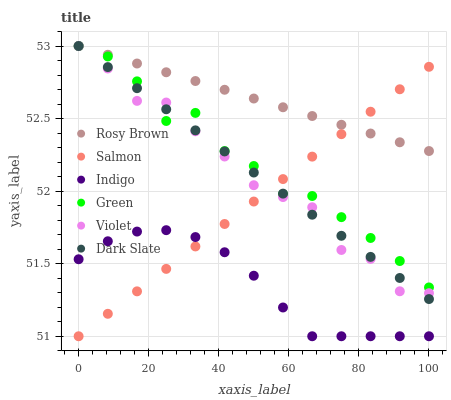Does Indigo have the minimum area under the curve?
Answer yes or no. Yes. Does Rosy Brown have the maximum area under the curve?
Answer yes or no. Yes. Does Salmon have the minimum area under the curve?
Answer yes or no. No. Does Salmon have the maximum area under the curve?
Answer yes or no. No. Is Salmon the smoothest?
Answer yes or no. Yes. Is Violet the roughest?
Answer yes or no. Yes. Is Rosy Brown the smoothest?
Answer yes or no. No. Is Rosy Brown the roughest?
Answer yes or no. No. Does Indigo have the lowest value?
Answer yes or no. Yes. Does Rosy Brown have the lowest value?
Answer yes or no. No. Does Violet have the highest value?
Answer yes or no. Yes. Does Salmon have the highest value?
Answer yes or no. No. Is Indigo less than Violet?
Answer yes or no. Yes. Is Violet greater than Indigo?
Answer yes or no. Yes. Does Green intersect Violet?
Answer yes or no. Yes. Is Green less than Violet?
Answer yes or no. No. Is Green greater than Violet?
Answer yes or no. No. Does Indigo intersect Violet?
Answer yes or no. No. 